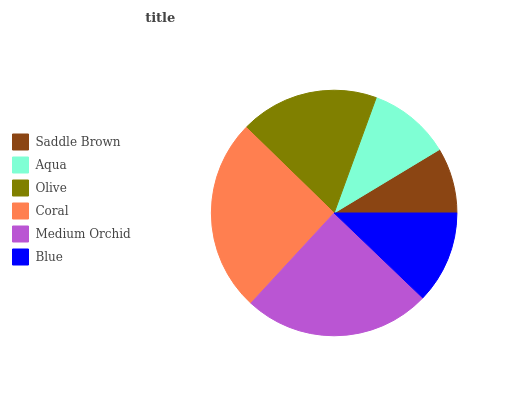Is Saddle Brown the minimum?
Answer yes or no. Yes. Is Coral the maximum?
Answer yes or no. Yes. Is Aqua the minimum?
Answer yes or no. No. Is Aqua the maximum?
Answer yes or no. No. Is Aqua greater than Saddle Brown?
Answer yes or no. Yes. Is Saddle Brown less than Aqua?
Answer yes or no. Yes. Is Saddle Brown greater than Aqua?
Answer yes or no. No. Is Aqua less than Saddle Brown?
Answer yes or no. No. Is Olive the high median?
Answer yes or no. Yes. Is Blue the low median?
Answer yes or no. Yes. Is Coral the high median?
Answer yes or no. No. Is Saddle Brown the low median?
Answer yes or no. No. 